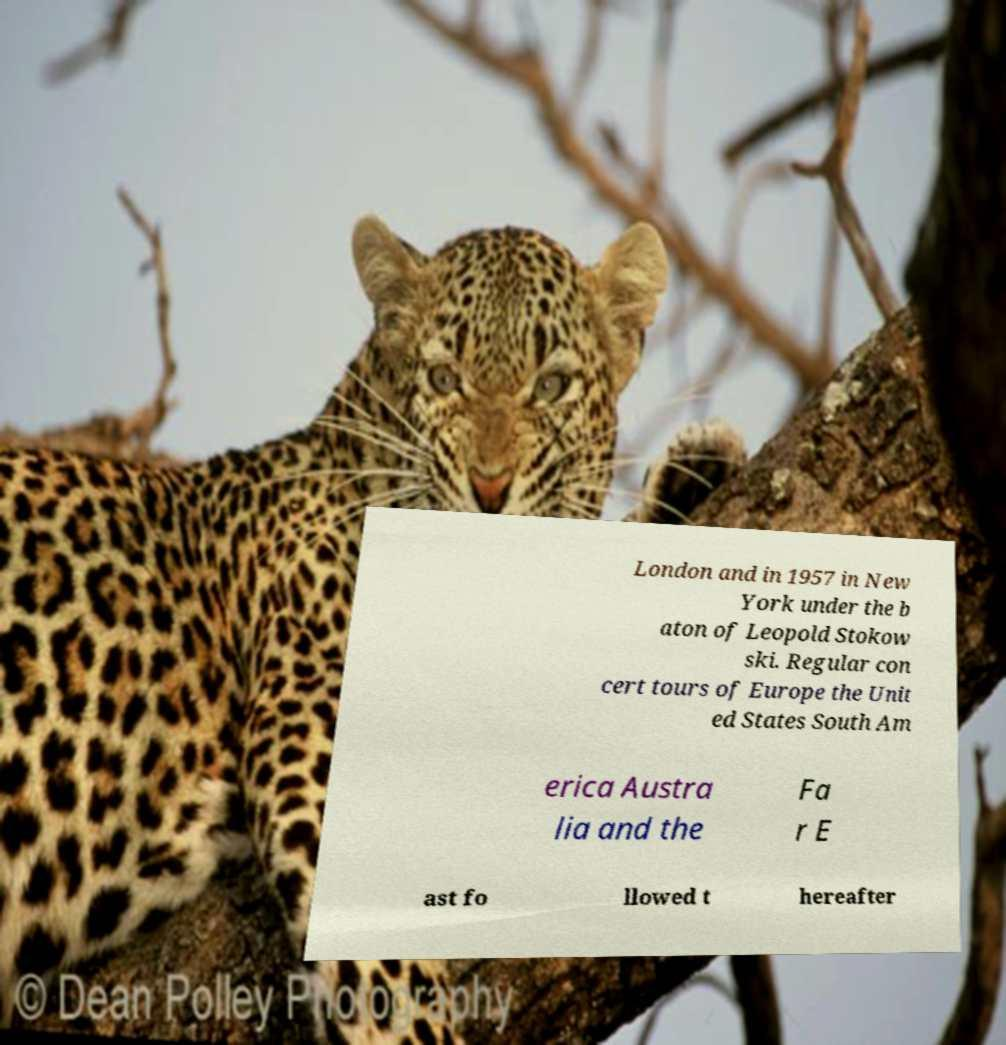Could you assist in decoding the text presented in this image and type it out clearly? London and in 1957 in New York under the b aton of Leopold Stokow ski. Regular con cert tours of Europe the Unit ed States South Am erica Austra lia and the Fa r E ast fo llowed t hereafter 